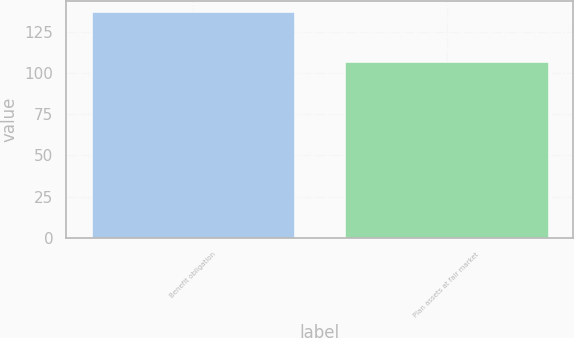<chart> <loc_0><loc_0><loc_500><loc_500><bar_chart><fcel>Benefit obligation<fcel>Plan assets at fair market<nl><fcel>136.8<fcel>106.7<nl></chart> 